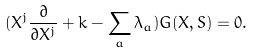<formula> <loc_0><loc_0><loc_500><loc_500>( X ^ { j } \frac { \partial } { \partial X ^ { j } } + k - \sum _ { a } \lambda _ { a } ) G ( X , S ) = 0 .</formula> 